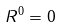<formula> <loc_0><loc_0><loc_500><loc_500>R ^ { 0 } = 0</formula> 